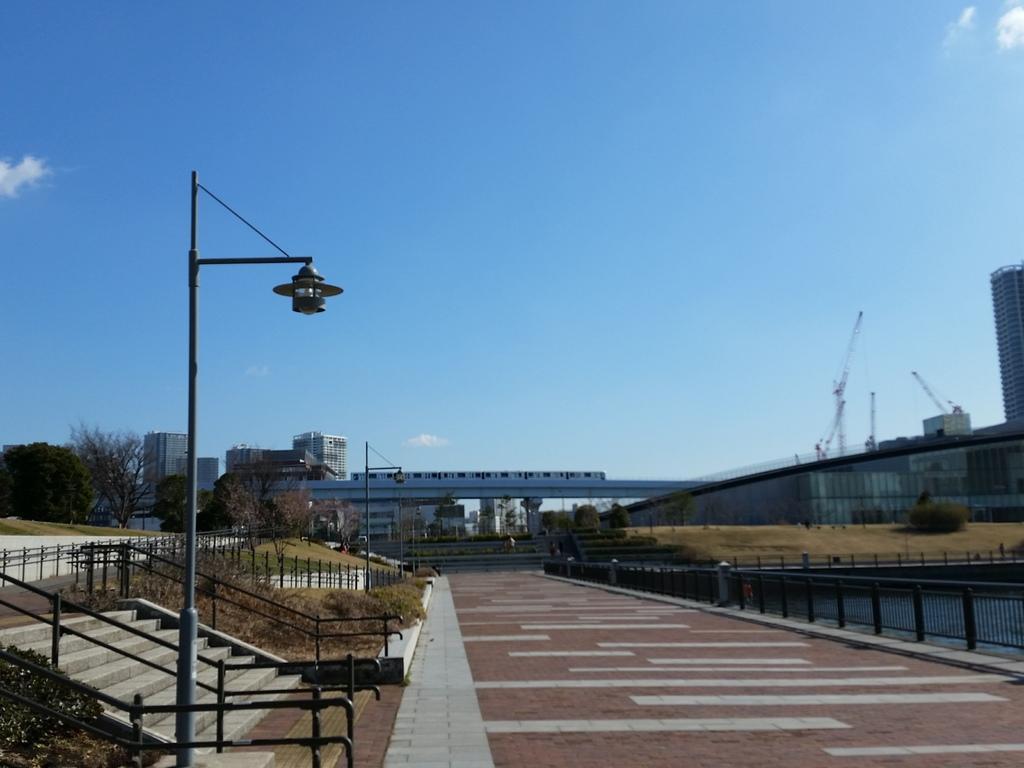In one or two sentences, can you explain what this image depicts? In this picture we can see road, side we can see some stare cases, grass, trees and we can see fencing, behind we can see some buildings. 